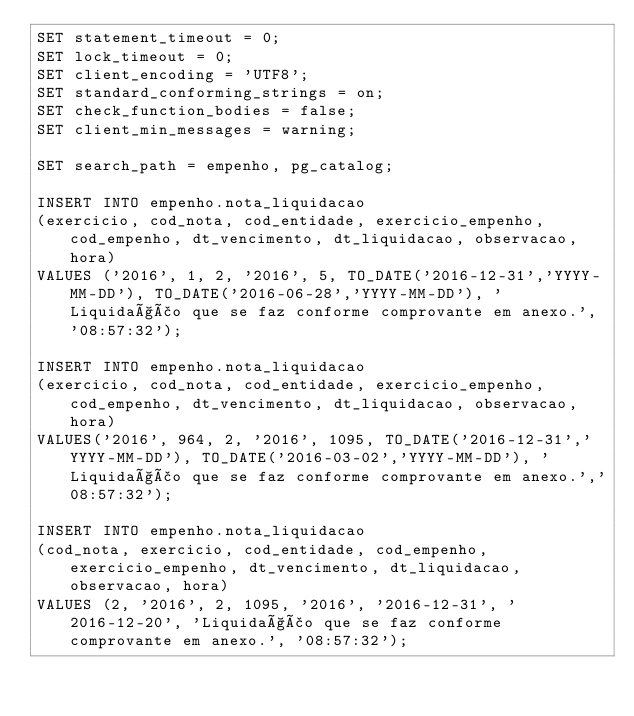<code> <loc_0><loc_0><loc_500><loc_500><_SQL_>SET statement_timeout = 0;
SET lock_timeout = 0;
SET client_encoding = 'UTF8';
SET standard_conforming_strings = on;
SET check_function_bodies = false;
SET client_min_messages = warning;

SET search_path = empenho, pg_catalog;

INSERT INTO empenho.nota_liquidacao
(exercicio, cod_nota, cod_entidade, exercicio_empenho, cod_empenho, dt_vencimento, dt_liquidacao, observacao, hora)
VALUES ('2016', 1, 2, '2016', 5, TO_DATE('2016-12-31','YYYY-MM-DD'), TO_DATE('2016-06-28','YYYY-MM-DD'), 'Liquidação que se faz conforme comprovante em anexo.', '08:57:32');

INSERT INTO empenho.nota_liquidacao
(exercicio, cod_nota, cod_entidade, exercicio_empenho, cod_empenho, dt_vencimento, dt_liquidacao, observacao, hora)
VALUES('2016', 964, 2, '2016', 1095, TO_DATE('2016-12-31','YYYY-MM-DD'), TO_DATE('2016-03-02','YYYY-MM-DD'), 'Liquidação que se faz conforme comprovante em anexo.','08:57:32');

INSERT INTO empenho.nota_liquidacao
(cod_nota, exercicio, cod_entidade, cod_empenho, exercicio_empenho, dt_vencimento, dt_liquidacao, observacao, hora)
VALUES (2, '2016', 2, 1095, '2016', '2016-12-31', '2016-12-20', 'Liquidação que se faz conforme comprovante em anexo.', '08:57:32');
</code> 